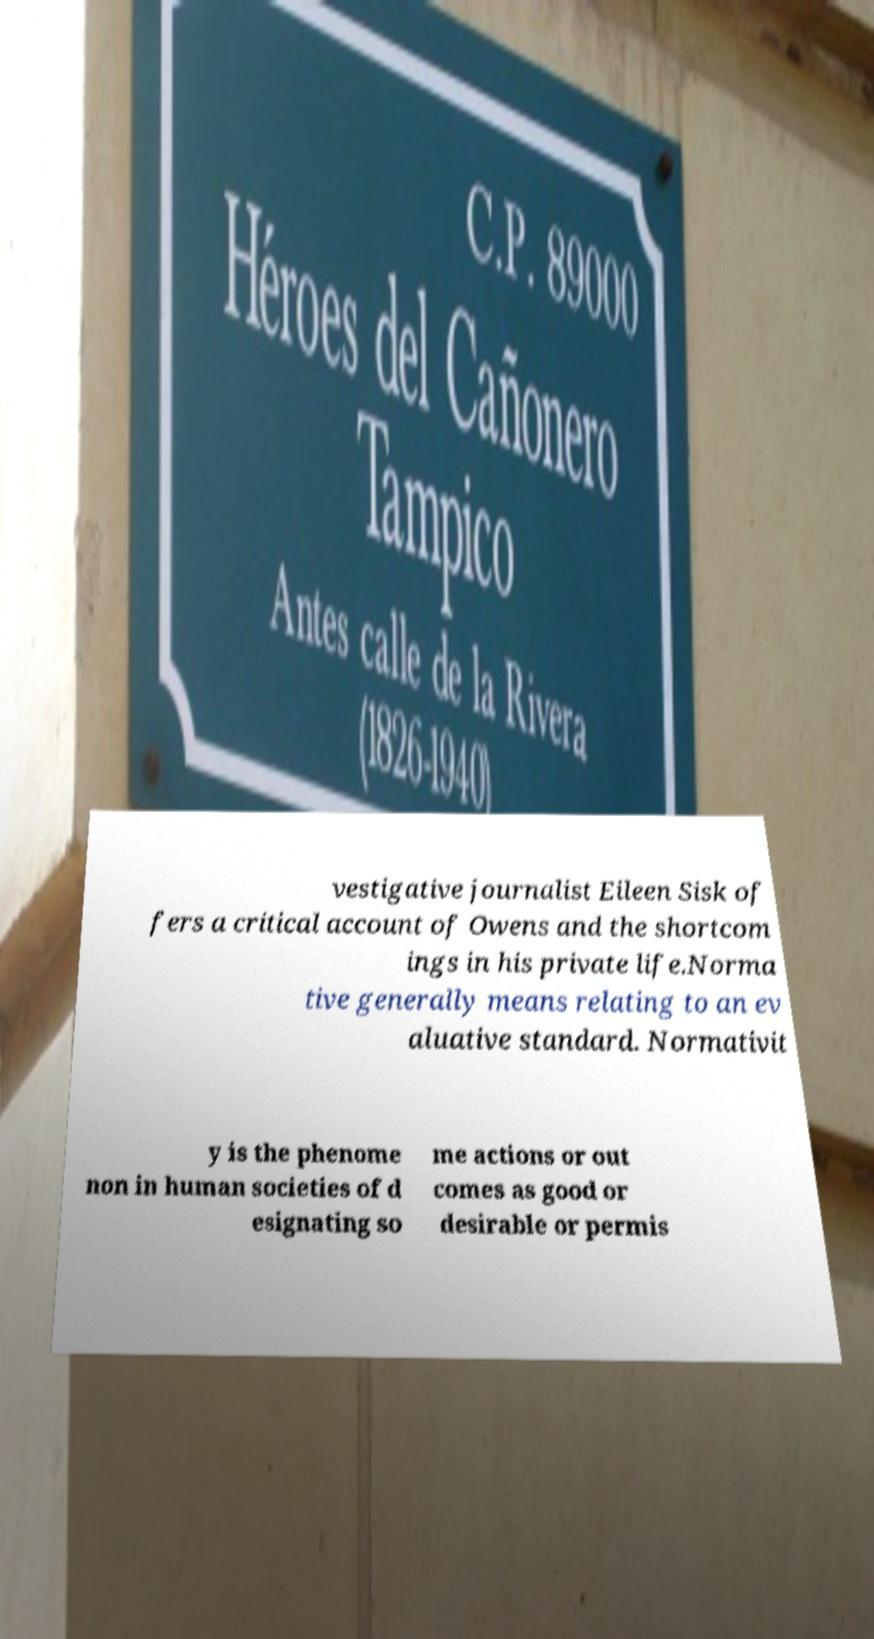I need the written content from this picture converted into text. Can you do that? vestigative journalist Eileen Sisk of fers a critical account of Owens and the shortcom ings in his private life.Norma tive generally means relating to an ev aluative standard. Normativit y is the phenome non in human societies of d esignating so me actions or out comes as good or desirable or permis 